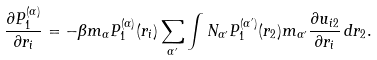Convert formula to latex. <formula><loc_0><loc_0><loc_500><loc_500>\frac { \partial P _ { 1 } ^ { ( \alpha ) } } { \partial r _ { i } } = - \beta m _ { \alpha } P _ { 1 } ^ { ( \alpha ) } ( r _ { i } ) \sum _ { \alpha ^ { \prime } } \int N _ { \alpha ^ { \prime } } P _ { 1 } ^ { ( \alpha ^ { \prime } ) } ( r _ { 2 } ) m _ { \alpha ^ { \prime } } \frac { \partial u _ { i 2 } } { \partial r _ { i } } \, d { r } _ { 2 } .</formula> 